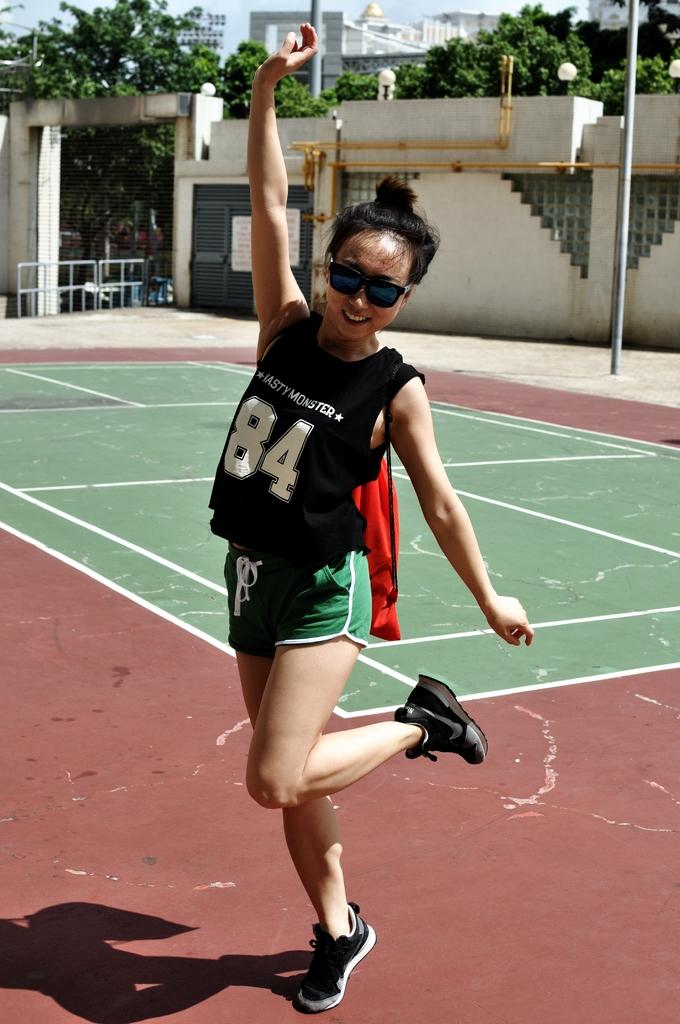What numbers are on her shirt?
Offer a terse response. 84. 